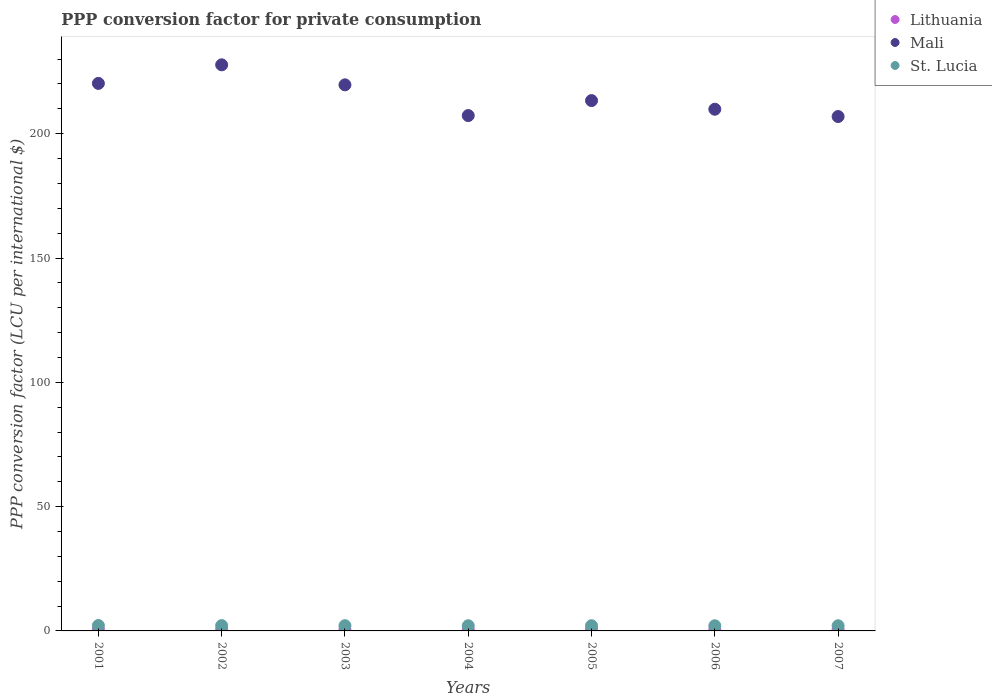What is the PPP conversion factor for private consumption in Mali in 2004?
Your response must be concise. 207.3. Across all years, what is the maximum PPP conversion factor for private consumption in Mali?
Ensure brevity in your answer.  227.71. Across all years, what is the minimum PPP conversion factor for private consumption in Mali?
Your answer should be very brief. 206.91. In which year was the PPP conversion factor for private consumption in St. Lucia minimum?
Make the answer very short. 2006. What is the total PPP conversion factor for private consumption in St. Lucia in the graph?
Provide a succinct answer. 14.71. What is the difference between the PPP conversion factor for private consumption in Lithuania in 2002 and that in 2007?
Give a very brief answer. -0.04. What is the difference between the PPP conversion factor for private consumption in Lithuania in 2003 and the PPP conversion factor for private consumption in Mali in 2001?
Offer a very short reply. -219.78. What is the average PPP conversion factor for private consumption in Lithuania per year?
Your response must be concise. 0.48. In the year 2001, what is the difference between the PPP conversion factor for private consumption in Mali and PPP conversion factor for private consumption in St. Lucia?
Your answer should be compact. 218.07. What is the ratio of the PPP conversion factor for private consumption in Lithuania in 2003 to that in 2007?
Make the answer very short. 0.88. What is the difference between the highest and the second highest PPP conversion factor for private consumption in Lithuania?
Offer a terse response. 0.02. What is the difference between the highest and the lowest PPP conversion factor for private consumption in Mali?
Provide a short and direct response. 20.8. Is the sum of the PPP conversion factor for private consumption in Lithuania in 2001 and 2006 greater than the maximum PPP conversion factor for private consumption in St. Lucia across all years?
Offer a very short reply. No. Is it the case that in every year, the sum of the PPP conversion factor for private consumption in St. Lucia and PPP conversion factor for private consumption in Mali  is greater than the PPP conversion factor for private consumption in Lithuania?
Your answer should be compact. Yes. How many dotlines are there?
Offer a very short reply. 3. Are the values on the major ticks of Y-axis written in scientific E-notation?
Offer a terse response. No. Does the graph contain grids?
Offer a very short reply. No. How many legend labels are there?
Your response must be concise. 3. How are the legend labels stacked?
Your answer should be compact. Vertical. What is the title of the graph?
Your answer should be compact. PPP conversion factor for private consumption. What is the label or title of the X-axis?
Make the answer very short. Years. What is the label or title of the Y-axis?
Make the answer very short. PPP conversion factor (LCU per international $). What is the PPP conversion factor (LCU per international $) of Lithuania in 2001?
Provide a succinct answer. 0.5. What is the PPP conversion factor (LCU per international $) of Mali in 2001?
Provide a succinct answer. 220.24. What is the PPP conversion factor (LCU per international $) in St. Lucia in 2001?
Your answer should be very brief. 2.17. What is the PPP conversion factor (LCU per international $) of Lithuania in 2002?
Give a very brief answer. 0.48. What is the PPP conversion factor (LCU per international $) in Mali in 2002?
Offer a very short reply. 227.71. What is the PPP conversion factor (LCU per international $) in St. Lucia in 2002?
Provide a short and direct response. 2.13. What is the PPP conversion factor (LCU per international $) in Lithuania in 2003?
Your answer should be very brief. 0.46. What is the PPP conversion factor (LCU per international $) of Mali in 2003?
Make the answer very short. 219.66. What is the PPP conversion factor (LCU per international $) of St. Lucia in 2003?
Your answer should be very brief. 2.1. What is the PPP conversion factor (LCU per international $) of Lithuania in 2004?
Keep it short and to the point. 0.46. What is the PPP conversion factor (LCU per international $) in Mali in 2004?
Offer a very short reply. 207.3. What is the PPP conversion factor (LCU per international $) of St. Lucia in 2004?
Keep it short and to the point. 2.08. What is the PPP conversion factor (LCU per international $) of Lithuania in 2005?
Provide a short and direct response. 0.48. What is the PPP conversion factor (LCU per international $) in Mali in 2005?
Offer a very short reply. 213.32. What is the PPP conversion factor (LCU per international $) of St. Lucia in 2005?
Keep it short and to the point. 2.09. What is the PPP conversion factor (LCU per international $) of Lithuania in 2006?
Offer a terse response. 0.49. What is the PPP conversion factor (LCU per international $) in Mali in 2006?
Keep it short and to the point. 209.85. What is the PPP conversion factor (LCU per international $) of St. Lucia in 2006?
Offer a terse response. 2.07. What is the PPP conversion factor (LCU per international $) of Lithuania in 2007?
Make the answer very short. 0.52. What is the PPP conversion factor (LCU per international $) in Mali in 2007?
Provide a succinct answer. 206.91. What is the PPP conversion factor (LCU per international $) of St. Lucia in 2007?
Provide a succinct answer. 2.08. Across all years, what is the maximum PPP conversion factor (LCU per international $) of Lithuania?
Ensure brevity in your answer.  0.52. Across all years, what is the maximum PPP conversion factor (LCU per international $) of Mali?
Offer a terse response. 227.71. Across all years, what is the maximum PPP conversion factor (LCU per international $) in St. Lucia?
Provide a succinct answer. 2.17. Across all years, what is the minimum PPP conversion factor (LCU per international $) of Lithuania?
Provide a succinct answer. 0.46. Across all years, what is the minimum PPP conversion factor (LCU per international $) of Mali?
Provide a short and direct response. 206.91. Across all years, what is the minimum PPP conversion factor (LCU per international $) of St. Lucia?
Provide a short and direct response. 2.07. What is the total PPP conversion factor (LCU per international $) of Lithuania in the graph?
Make the answer very short. 3.38. What is the total PPP conversion factor (LCU per international $) of Mali in the graph?
Make the answer very short. 1504.99. What is the total PPP conversion factor (LCU per international $) in St. Lucia in the graph?
Offer a very short reply. 14.71. What is the difference between the PPP conversion factor (LCU per international $) of Lithuania in 2001 and that in 2002?
Your answer should be compact. 0.02. What is the difference between the PPP conversion factor (LCU per international $) of Mali in 2001 and that in 2002?
Provide a succinct answer. -7.47. What is the difference between the PPP conversion factor (LCU per international $) of St. Lucia in 2001 and that in 2002?
Provide a succinct answer. 0.04. What is the difference between the PPP conversion factor (LCU per international $) of Lithuania in 2001 and that in 2003?
Provide a short and direct response. 0.04. What is the difference between the PPP conversion factor (LCU per international $) of Mali in 2001 and that in 2003?
Your response must be concise. 0.58. What is the difference between the PPP conversion factor (LCU per international $) in St. Lucia in 2001 and that in 2003?
Provide a short and direct response. 0.07. What is the difference between the PPP conversion factor (LCU per international $) in Lithuania in 2001 and that in 2004?
Make the answer very short. 0.03. What is the difference between the PPP conversion factor (LCU per international $) in Mali in 2001 and that in 2004?
Your answer should be compact. 12.94. What is the difference between the PPP conversion factor (LCU per international $) of St. Lucia in 2001 and that in 2004?
Give a very brief answer. 0.09. What is the difference between the PPP conversion factor (LCU per international $) in Lithuania in 2001 and that in 2005?
Make the answer very short. 0.02. What is the difference between the PPP conversion factor (LCU per international $) in Mali in 2001 and that in 2005?
Provide a succinct answer. 6.91. What is the difference between the PPP conversion factor (LCU per international $) in St. Lucia in 2001 and that in 2005?
Offer a terse response. 0.08. What is the difference between the PPP conversion factor (LCU per international $) of Lithuania in 2001 and that in 2006?
Your answer should be very brief. 0. What is the difference between the PPP conversion factor (LCU per international $) in Mali in 2001 and that in 2006?
Provide a short and direct response. 10.39. What is the difference between the PPP conversion factor (LCU per international $) of St. Lucia in 2001 and that in 2006?
Offer a terse response. 0.1. What is the difference between the PPP conversion factor (LCU per international $) of Lithuania in 2001 and that in 2007?
Provide a succinct answer. -0.02. What is the difference between the PPP conversion factor (LCU per international $) of Mali in 2001 and that in 2007?
Your answer should be compact. 13.33. What is the difference between the PPP conversion factor (LCU per international $) in St. Lucia in 2001 and that in 2007?
Offer a very short reply. 0.09. What is the difference between the PPP conversion factor (LCU per international $) of Lithuania in 2002 and that in 2003?
Provide a succinct answer. 0.02. What is the difference between the PPP conversion factor (LCU per international $) of Mali in 2002 and that in 2003?
Provide a short and direct response. 8.05. What is the difference between the PPP conversion factor (LCU per international $) of St. Lucia in 2002 and that in 2003?
Provide a succinct answer. 0.03. What is the difference between the PPP conversion factor (LCU per international $) in Lithuania in 2002 and that in 2004?
Your answer should be very brief. 0.02. What is the difference between the PPP conversion factor (LCU per international $) in Mali in 2002 and that in 2004?
Your answer should be compact. 20.41. What is the difference between the PPP conversion factor (LCU per international $) of St. Lucia in 2002 and that in 2004?
Your response must be concise. 0.05. What is the difference between the PPP conversion factor (LCU per international $) in Lithuania in 2002 and that in 2005?
Keep it short and to the point. 0. What is the difference between the PPP conversion factor (LCU per international $) in Mali in 2002 and that in 2005?
Give a very brief answer. 14.39. What is the difference between the PPP conversion factor (LCU per international $) in St. Lucia in 2002 and that in 2005?
Your response must be concise. 0.04. What is the difference between the PPP conversion factor (LCU per international $) of Lithuania in 2002 and that in 2006?
Make the answer very short. -0.01. What is the difference between the PPP conversion factor (LCU per international $) of Mali in 2002 and that in 2006?
Your answer should be very brief. 17.86. What is the difference between the PPP conversion factor (LCU per international $) of St. Lucia in 2002 and that in 2006?
Offer a very short reply. 0.06. What is the difference between the PPP conversion factor (LCU per international $) in Lithuania in 2002 and that in 2007?
Your answer should be compact. -0.04. What is the difference between the PPP conversion factor (LCU per international $) of Mali in 2002 and that in 2007?
Your answer should be very brief. 20.8. What is the difference between the PPP conversion factor (LCU per international $) of St. Lucia in 2002 and that in 2007?
Provide a short and direct response. 0.05. What is the difference between the PPP conversion factor (LCU per international $) of Lithuania in 2003 and that in 2004?
Offer a very short reply. -0.01. What is the difference between the PPP conversion factor (LCU per international $) of Mali in 2003 and that in 2004?
Ensure brevity in your answer.  12.36. What is the difference between the PPP conversion factor (LCU per international $) in St. Lucia in 2003 and that in 2004?
Offer a terse response. 0.02. What is the difference between the PPP conversion factor (LCU per international $) of Lithuania in 2003 and that in 2005?
Your response must be concise. -0.02. What is the difference between the PPP conversion factor (LCU per international $) in Mali in 2003 and that in 2005?
Give a very brief answer. 6.33. What is the difference between the PPP conversion factor (LCU per international $) of St. Lucia in 2003 and that in 2005?
Your response must be concise. 0.01. What is the difference between the PPP conversion factor (LCU per international $) of Lithuania in 2003 and that in 2006?
Offer a terse response. -0.04. What is the difference between the PPP conversion factor (LCU per international $) of Mali in 2003 and that in 2006?
Your answer should be compact. 9.81. What is the difference between the PPP conversion factor (LCU per international $) in St. Lucia in 2003 and that in 2006?
Make the answer very short. 0.03. What is the difference between the PPP conversion factor (LCU per international $) in Lithuania in 2003 and that in 2007?
Your response must be concise. -0.06. What is the difference between the PPP conversion factor (LCU per international $) in Mali in 2003 and that in 2007?
Provide a succinct answer. 12.75. What is the difference between the PPP conversion factor (LCU per international $) in St. Lucia in 2003 and that in 2007?
Keep it short and to the point. 0.03. What is the difference between the PPP conversion factor (LCU per international $) in Lithuania in 2004 and that in 2005?
Offer a very short reply. -0.01. What is the difference between the PPP conversion factor (LCU per international $) of Mali in 2004 and that in 2005?
Your answer should be compact. -6.03. What is the difference between the PPP conversion factor (LCU per international $) in St. Lucia in 2004 and that in 2005?
Your response must be concise. -0.01. What is the difference between the PPP conversion factor (LCU per international $) of Lithuania in 2004 and that in 2006?
Your answer should be very brief. -0.03. What is the difference between the PPP conversion factor (LCU per international $) in Mali in 2004 and that in 2006?
Keep it short and to the point. -2.55. What is the difference between the PPP conversion factor (LCU per international $) in St. Lucia in 2004 and that in 2006?
Give a very brief answer. 0.01. What is the difference between the PPP conversion factor (LCU per international $) of Lithuania in 2004 and that in 2007?
Offer a very short reply. -0.05. What is the difference between the PPP conversion factor (LCU per international $) in Mali in 2004 and that in 2007?
Provide a succinct answer. 0.39. What is the difference between the PPP conversion factor (LCU per international $) in St. Lucia in 2004 and that in 2007?
Provide a succinct answer. 0. What is the difference between the PPP conversion factor (LCU per international $) in Lithuania in 2005 and that in 2006?
Offer a very short reply. -0.02. What is the difference between the PPP conversion factor (LCU per international $) of Mali in 2005 and that in 2006?
Provide a short and direct response. 3.48. What is the difference between the PPP conversion factor (LCU per international $) of St. Lucia in 2005 and that in 2006?
Provide a short and direct response. 0.02. What is the difference between the PPP conversion factor (LCU per international $) of Lithuania in 2005 and that in 2007?
Your answer should be very brief. -0.04. What is the difference between the PPP conversion factor (LCU per international $) of Mali in 2005 and that in 2007?
Ensure brevity in your answer.  6.42. What is the difference between the PPP conversion factor (LCU per international $) in St. Lucia in 2005 and that in 2007?
Provide a short and direct response. 0.01. What is the difference between the PPP conversion factor (LCU per international $) of Lithuania in 2006 and that in 2007?
Provide a succinct answer. -0.02. What is the difference between the PPP conversion factor (LCU per international $) of Mali in 2006 and that in 2007?
Keep it short and to the point. 2.94. What is the difference between the PPP conversion factor (LCU per international $) in St. Lucia in 2006 and that in 2007?
Your response must be concise. -0. What is the difference between the PPP conversion factor (LCU per international $) in Lithuania in 2001 and the PPP conversion factor (LCU per international $) in Mali in 2002?
Provide a succinct answer. -227.21. What is the difference between the PPP conversion factor (LCU per international $) in Lithuania in 2001 and the PPP conversion factor (LCU per international $) in St. Lucia in 2002?
Provide a succinct answer. -1.63. What is the difference between the PPP conversion factor (LCU per international $) of Mali in 2001 and the PPP conversion factor (LCU per international $) of St. Lucia in 2002?
Ensure brevity in your answer.  218.11. What is the difference between the PPP conversion factor (LCU per international $) of Lithuania in 2001 and the PPP conversion factor (LCU per international $) of Mali in 2003?
Make the answer very short. -219.16. What is the difference between the PPP conversion factor (LCU per international $) of Lithuania in 2001 and the PPP conversion factor (LCU per international $) of St. Lucia in 2003?
Your answer should be very brief. -1.61. What is the difference between the PPP conversion factor (LCU per international $) of Mali in 2001 and the PPP conversion factor (LCU per international $) of St. Lucia in 2003?
Keep it short and to the point. 218.14. What is the difference between the PPP conversion factor (LCU per international $) in Lithuania in 2001 and the PPP conversion factor (LCU per international $) in Mali in 2004?
Your response must be concise. -206.8. What is the difference between the PPP conversion factor (LCU per international $) of Lithuania in 2001 and the PPP conversion factor (LCU per international $) of St. Lucia in 2004?
Your answer should be very brief. -1.58. What is the difference between the PPP conversion factor (LCU per international $) in Mali in 2001 and the PPP conversion factor (LCU per international $) in St. Lucia in 2004?
Provide a short and direct response. 218.16. What is the difference between the PPP conversion factor (LCU per international $) in Lithuania in 2001 and the PPP conversion factor (LCU per international $) in Mali in 2005?
Your answer should be compact. -212.83. What is the difference between the PPP conversion factor (LCU per international $) of Lithuania in 2001 and the PPP conversion factor (LCU per international $) of St. Lucia in 2005?
Offer a very short reply. -1.59. What is the difference between the PPP conversion factor (LCU per international $) of Mali in 2001 and the PPP conversion factor (LCU per international $) of St. Lucia in 2005?
Give a very brief answer. 218.15. What is the difference between the PPP conversion factor (LCU per international $) of Lithuania in 2001 and the PPP conversion factor (LCU per international $) of Mali in 2006?
Offer a terse response. -209.35. What is the difference between the PPP conversion factor (LCU per international $) of Lithuania in 2001 and the PPP conversion factor (LCU per international $) of St. Lucia in 2006?
Provide a short and direct response. -1.57. What is the difference between the PPP conversion factor (LCU per international $) in Mali in 2001 and the PPP conversion factor (LCU per international $) in St. Lucia in 2006?
Give a very brief answer. 218.17. What is the difference between the PPP conversion factor (LCU per international $) of Lithuania in 2001 and the PPP conversion factor (LCU per international $) of Mali in 2007?
Your answer should be very brief. -206.41. What is the difference between the PPP conversion factor (LCU per international $) of Lithuania in 2001 and the PPP conversion factor (LCU per international $) of St. Lucia in 2007?
Provide a short and direct response. -1.58. What is the difference between the PPP conversion factor (LCU per international $) in Mali in 2001 and the PPP conversion factor (LCU per international $) in St. Lucia in 2007?
Give a very brief answer. 218.16. What is the difference between the PPP conversion factor (LCU per international $) of Lithuania in 2002 and the PPP conversion factor (LCU per international $) of Mali in 2003?
Keep it short and to the point. -219.18. What is the difference between the PPP conversion factor (LCU per international $) in Lithuania in 2002 and the PPP conversion factor (LCU per international $) in St. Lucia in 2003?
Keep it short and to the point. -1.62. What is the difference between the PPP conversion factor (LCU per international $) in Mali in 2002 and the PPP conversion factor (LCU per international $) in St. Lucia in 2003?
Provide a short and direct response. 225.61. What is the difference between the PPP conversion factor (LCU per international $) of Lithuania in 2002 and the PPP conversion factor (LCU per international $) of Mali in 2004?
Your answer should be very brief. -206.82. What is the difference between the PPP conversion factor (LCU per international $) in Lithuania in 2002 and the PPP conversion factor (LCU per international $) in St. Lucia in 2004?
Your answer should be very brief. -1.6. What is the difference between the PPP conversion factor (LCU per international $) in Mali in 2002 and the PPP conversion factor (LCU per international $) in St. Lucia in 2004?
Provide a succinct answer. 225.63. What is the difference between the PPP conversion factor (LCU per international $) of Lithuania in 2002 and the PPP conversion factor (LCU per international $) of Mali in 2005?
Your answer should be very brief. -212.84. What is the difference between the PPP conversion factor (LCU per international $) of Lithuania in 2002 and the PPP conversion factor (LCU per international $) of St. Lucia in 2005?
Give a very brief answer. -1.61. What is the difference between the PPP conversion factor (LCU per international $) of Mali in 2002 and the PPP conversion factor (LCU per international $) of St. Lucia in 2005?
Your answer should be compact. 225.62. What is the difference between the PPP conversion factor (LCU per international $) in Lithuania in 2002 and the PPP conversion factor (LCU per international $) in Mali in 2006?
Your answer should be compact. -209.37. What is the difference between the PPP conversion factor (LCU per international $) of Lithuania in 2002 and the PPP conversion factor (LCU per international $) of St. Lucia in 2006?
Ensure brevity in your answer.  -1.59. What is the difference between the PPP conversion factor (LCU per international $) in Mali in 2002 and the PPP conversion factor (LCU per international $) in St. Lucia in 2006?
Your answer should be compact. 225.64. What is the difference between the PPP conversion factor (LCU per international $) of Lithuania in 2002 and the PPP conversion factor (LCU per international $) of Mali in 2007?
Your answer should be very brief. -206.43. What is the difference between the PPP conversion factor (LCU per international $) of Lithuania in 2002 and the PPP conversion factor (LCU per international $) of St. Lucia in 2007?
Make the answer very short. -1.6. What is the difference between the PPP conversion factor (LCU per international $) of Mali in 2002 and the PPP conversion factor (LCU per international $) of St. Lucia in 2007?
Make the answer very short. 225.64. What is the difference between the PPP conversion factor (LCU per international $) in Lithuania in 2003 and the PPP conversion factor (LCU per international $) in Mali in 2004?
Offer a terse response. -206.84. What is the difference between the PPP conversion factor (LCU per international $) of Lithuania in 2003 and the PPP conversion factor (LCU per international $) of St. Lucia in 2004?
Keep it short and to the point. -1.62. What is the difference between the PPP conversion factor (LCU per international $) of Mali in 2003 and the PPP conversion factor (LCU per international $) of St. Lucia in 2004?
Your response must be concise. 217.58. What is the difference between the PPP conversion factor (LCU per international $) of Lithuania in 2003 and the PPP conversion factor (LCU per international $) of Mali in 2005?
Make the answer very short. -212.87. What is the difference between the PPP conversion factor (LCU per international $) of Lithuania in 2003 and the PPP conversion factor (LCU per international $) of St. Lucia in 2005?
Your response must be concise. -1.63. What is the difference between the PPP conversion factor (LCU per international $) of Mali in 2003 and the PPP conversion factor (LCU per international $) of St. Lucia in 2005?
Keep it short and to the point. 217.57. What is the difference between the PPP conversion factor (LCU per international $) in Lithuania in 2003 and the PPP conversion factor (LCU per international $) in Mali in 2006?
Your answer should be compact. -209.39. What is the difference between the PPP conversion factor (LCU per international $) in Lithuania in 2003 and the PPP conversion factor (LCU per international $) in St. Lucia in 2006?
Your response must be concise. -1.62. What is the difference between the PPP conversion factor (LCU per international $) in Mali in 2003 and the PPP conversion factor (LCU per international $) in St. Lucia in 2006?
Make the answer very short. 217.59. What is the difference between the PPP conversion factor (LCU per international $) of Lithuania in 2003 and the PPP conversion factor (LCU per international $) of Mali in 2007?
Your answer should be very brief. -206.45. What is the difference between the PPP conversion factor (LCU per international $) of Lithuania in 2003 and the PPP conversion factor (LCU per international $) of St. Lucia in 2007?
Offer a very short reply. -1.62. What is the difference between the PPP conversion factor (LCU per international $) of Mali in 2003 and the PPP conversion factor (LCU per international $) of St. Lucia in 2007?
Offer a terse response. 217.58. What is the difference between the PPP conversion factor (LCU per international $) of Lithuania in 2004 and the PPP conversion factor (LCU per international $) of Mali in 2005?
Your answer should be compact. -212.86. What is the difference between the PPP conversion factor (LCU per international $) of Lithuania in 2004 and the PPP conversion factor (LCU per international $) of St. Lucia in 2005?
Ensure brevity in your answer.  -1.63. What is the difference between the PPP conversion factor (LCU per international $) in Mali in 2004 and the PPP conversion factor (LCU per international $) in St. Lucia in 2005?
Keep it short and to the point. 205.21. What is the difference between the PPP conversion factor (LCU per international $) of Lithuania in 2004 and the PPP conversion factor (LCU per international $) of Mali in 2006?
Ensure brevity in your answer.  -209.38. What is the difference between the PPP conversion factor (LCU per international $) in Lithuania in 2004 and the PPP conversion factor (LCU per international $) in St. Lucia in 2006?
Offer a terse response. -1.61. What is the difference between the PPP conversion factor (LCU per international $) in Mali in 2004 and the PPP conversion factor (LCU per international $) in St. Lucia in 2006?
Keep it short and to the point. 205.23. What is the difference between the PPP conversion factor (LCU per international $) of Lithuania in 2004 and the PPP conversion factor (LCU per international $) of Mali in 2007?
Offer a terse response. -206.44. What is the difference between the PPP conversion factor (LCU per international $) in Lithuania in 2004 and the PPP conversion factor (LCU per international $) in St. Lucia in 2007?
Provide a succinct answer. -1.61. What is the difference between the PPP conversion factor (LCU per international $) in Mali in 2004 and the PPP conversion factor (LCU per international $) in St. Lucia in 2007?
Make the answer very short. 205.22. What is the difference between the PPP conversion factor (LCU per international $) in Lithuania in 2005 and the PPP conversion factor (LCU per international $) in Mali in 2006?
Offer a very short reply. -209.37. What is the difference between the PPP conversion factor (LCU per international $) of Lithuania in 2005 and the PPP conversion factor (LCU per international $) of St. Lucia in 2006?
Offer a terse response. -1.59. What is the difference between the PPP conversion factor (LCU per international $) in Mali in 2005 and the PPP conversion factor (LCU per international $) in St. Lucia in 2006?
Provide a succinct answer. 211.25. What is the difference between the PPP conversion factor (LCU per international $) of Lithuania in 2005 and the PPP conversion factor (LCU per international $) of Mali in 2007?
Offer a terse response. -206.43. What is the difference between the PPP conversion factor (LCU per international $) of Lithuania in 2005 and the PPP conversion factor (LCU per international $) of St. Lucia in 2007?
Keep it short and to the point. -1.6. What is the difference between the PPP conversion factor (LCU per international $) in Mali in 2005 and the PPP conversion factor (LCU per international $) in St. Lucia in 2007?
Make the answer very short. 211.25. What is the difference between the PPP conversion factor (LCU per international $) in Lithuania in 2006 and the PPP conversion factor (LCU per international $) in Mali in 2007?
Ensure brevity in your answer.  -206.42. What is the difference between the PPP conversion factor (LCU per international $) in Lithuania in 2006 and the PPP conversion factor (LCU per international $) in St. Lucia in 2007?
Offer a very short reply. -1.58. What is the difference between the PPP conversion factor (LCU per international $) in Mali in 2006 and the PPP conversion factor (LCU per international $) in St. Lucia in 2007?
Provide a short and direct response. 207.77. What is the average PPP conversion factor (LCU per international $) in Lithuania per year?
Provide a succinct answer. 0.48. What is the average PPP conversion factor (LCU per international $) of Mali per year?
Offer a very short reply. 215. What is the average PPP conversion factor (LCU per international $) in St. Lucia per year?
Your answer should be very brief. 2.1. In the year 2001, what is the difference between the PPP conversion factor (LCU per international $) of Lithuania and PPP conversion factor (LCU per international $) of Mali?
Provide a short and direct response. -219.74. In the year 2001, what is the difference between the PPP conversion factor (LCU per international $) of Lithuania and PPP conversion factor (LCU per international $) of St. Lucia?
Offer a terse response. -1.67. In the year 2001, what is the difference between the PPP conversion factor (LCU per international $) of Mali and PPP conversion factor (LCU per international $) of St. Lucia?
Provide a succinct answer. 218.07. In the year 2002, what is the difference between the PPP conversion factor (LCU per international $) in Lithuania and PPP conversion factor (LCU per international $) in Mali?
Your answer should be compact. -227.23. In the year 2002, what is the difference between the PPP conversion factor (LCU per international $) of Lithuania and PPP conversion factor (LCU per international $) of St. Lucia?
Make the answer very short. -1.65. In the year 2002, what is the difference between the PPP conversion factor (LCU per international $) in Mali and PPP conversion factor (LCU per international $) in St. Lucia?
Offer a very short reply. 225.58. In the year 2003, what is the difference between the PPP conversion factor (LCU per international $) of Lithuania and PPP conversion factor (LCU per international $) of Mali?
Provide a short and direct response. -219.2. In the year 2003, what is the difference between the PPP conversion factor (LCU per international $) in Lithuania and PPP conversion factor (LCU per international $) in St. Lucia?
Provide a succinct answer. -1.65. In the year 2003, what is the difference between the PPP conversion factor (LCU per international $) in Mali and PPP conversion factor (LCU per international $) in St. Lucia?
Your answer should be compact. 217.55. In the year 2004, what is the difference between the PPP conversion factor (LCU per international $) of Lithuania and PPP conversion factor (LCU per international $) of Mali?
Keep it short and to the point. -206.84. In the year 2004, what is the difference between the PPP conversion factor (LCU per international $) in Lithuania and PPP conversion factor (LCU per international $) in St. Lucia?
Make the answer very short. -1.61. In the year 2004, what is the difference between the PPP conversion factor (LCU per international $) of Mali and PPP conversion factor (LCU per international $) of St. Lucia?
Keep it short and to the point. 205.22. In the year 2005, what is the difference between the PPP conversion factor (LCU per international $) in Lithuania and PPP conversion factor (LCU per international $) in Mali?
Ensure brevity in your answer.  -212.85. In the year 2005, what is the difference between the PPP conversion factor (LCU per international $) of Lithuania and PPP conversion factor (LCU per international $) of St. Lucia?
Provide a short and direct response. -1.61. In the year 2005, what is the difference between the PPP conversion factor (LCU per international $) of Mali and PPP conversion factor (LCU per international $) of St. Lucia?
Provide a succinct answer. 211.24. In the year 2006, what is the difference between the PPP conversion factor (LCU per international $) in Lithuania and PPP conversion factor (LCU per international $) in Mali?
Give a very brief answer. -209.36. In the year 2006, what is the difference between the PPP conversion factor (LCU per international $) of Lithuania and PPP conversion factor (LCU per international $) of St. Lucia?
Your answer should be compact. -1.58. In the year 2006, what is the difference between the PPP conversion factor (LCU per international $) of Mali and PPP conversion factor (LCU per international $) of St. Lucia?
Provide a short and direct response. 207.78. In the year 2007, what is the difference between the PPP conversion factor (LCU per international $) of Lithuania and PPP conversion factor (LCU per international $) of Mali?
Provide a short and direct response. -206.39. In the year 2007, what is the difference between the PPP conversion factor (LCU per international $) of Lithuania and PPP conversion factor (LCU per international $) of St. Lucia?
Keep it short and to the point. -1.56. In the year 2007, what is the difference between the PPP conversion factor (LCU per international $) of Mali and PPP conversion factor (LCU per international $) of St. Lucia?
Give a very brief answer. 204.83. What is the ratio of the PPP conversion factor (LCU per international $) in Lithuania in 2001 to that in 2002?
Provide a short and direct response. 1.04. What is the ratio of the PPP conversion factor (LCU per international $) in Mali in 2001 to that in 2002?
Provide a short and direct response. 0.97. What is the ratio of the PPP conversion factor (LCU per international $) of St. Lucia in 2001 to that in 2002?
Provide a succinct answer. 1.02. What is the ratio of the PPP conversion factor (LCU per international $) in Lithuania in 2001 to that in 2003?
Ensure brevity in your answer.  1.09. What is the ratio of the PPP conversion factor (LCU per international $) of Mali in 2001 to that in 2003?
Offer a very short reply. 1. What is the ratio of the PPP conversion factor (LCU per international $) of St. Lucia in 2001 to that in 2003?
Your response must be concise. 1.03. What is the ratio of the PPP conversion factor (LCU per international $) of Lithuania in 2001 to that in 2004?
Keep it short and to the point. 1.07. What is the ratio of the PPP conversion factor (LCU per international $) in Mali in 2001 to that in 2004?
Offer a terse response. 1.06. What is the ratio of the PPP conversion factor (LCU per international $) of St. Lucia in 2001 to that in 2004?
Offer a terse response. 1.04. What is the ratio of the PPP conversion factor (LCU per international $) in Lithuania in 2001 to that in 2005?
Your answer should be very brief. 1.04. What is the ratio of the PPP conversion factor (LCU per international $) of Mali in 2001 to that in 2005?
Make the answer very short. 1.03. What is the ratio of the PPP conversion factor (LCU per international $) in St. Lucia in 2001 to that in 2005?
Offer a terse response. 1.04. What is the ratio of the PPP conversion factor (LCU per international $) in Lithuania in 2001 to that in 2006?
Provide a short and direct response. 1.01. What is the ratio of the PPP conversion factor (LCU per international $) in Mali in 2001 to that in 2006?
Offer a very short reply. 1.05. What is the ratio of the PPP conversion factor (LCU per international $) of St. Lucia in 2001 to that in 2006?
Keep it short and to the point. 1.05. What is the ratio of the PPP conversion factor (LCU per international $) in Lithuania in 2001 to that in 2007?
Provide a succinct answer. 0.96. What is the ratio of the PPP conversion factor (LCU per international $) in Mali in 2001 to that in 2007?
Make the answer very short. 1.06. What is the ratio of the PPP conversion factor (LCU per international $) in St. Lucia in 2001 to that in 2007?
Your response must be concise. 1.04. What is the ratio of the PPP conversion factor (LCU per international $) of Lithuania in 2002 to that in 2003?
Give a very brief answer. 1.05. What is the ratio of the PPP conversion factor (LCU per international $) of Mali in 2002 to that in 2003?
Offer a terse response. 1.04. What is the ratio of the PPP conversion factor (LCU per international $) in St. Lucia in 2002 to that in 2003?
Offer a very short reply. 1.01. What is the ratio of the PPP conversion factor (LCU per international $) of Lithuania in 2002 to that in 2004?
Your response must be concise. 1.03. What is the ratio of the PPP conversion factor (LCU per international $) of Mali in 2002 to that in 2004?
Give a very brief answer. 1.1. What is the ratio of the PPP conversion factor (LCU per international $) in St. Lucia in 2002 to that in 2004?
Provide a short and direct response. 1.02. What is the ratio of the PPP conversion factor (LCU per international $) in Mali in 2002 to that in 2005?
Your answer should be compact. 1.07. What is the ratio of the PPP conversion factor (LCU per international $) in St. Lucia in 2002 to that in 2005?
Provide a short and direct response. 1.02. What is the ratio of the PPP conversion factor (LCU per international $) of Lithuania in 2002 to that in 2006?
Your answer should be compact. 0.97. What is the ratio of the PPP conversion factor (LCU per international $) of Mali in 2002 to that in 2006?
Offer a terse response. 1.09. What is the ratio of the PPP conversion factor (LCU per international $) in St. Lucia in 2002 to that in 2006?
Keep it short and to the point. 1.03. What is the ratio of the PPP conversion factor (LCU per international $) of Lithuania in 2002 to that in 2007?
Your response must be concise. 0.93. What is the ratio of the PPP conversion factor (LCU per international $) in Mali in 2002 to that in 2007?
Provide a succinct answer. 1.1. What is the ratio of the PPP conversion factor (LCU per international $) of St. Lucia in 2002 to that in 2007?
Your response must be concise. 1.03. What is the ratio of the PPP conversion factor (LCU per international $) of Lithuania in 2003 to that in 2004?
Your answer should be very brief. 0.98. What is the ratio of the PPP conversion factor (LCU per international $) in Mali in 2003 to that in 2004?
Offer a very short reply. 1.06. What is the ratio of the PPP conversion factor (LCU per international $) in St. Lucia in 2003 to that in 2004?
Give a very brief answer. 1.01. What is the ratio of the PPP conversion factor (LCU per international $) in Lithuania in 2003 to that in 2005?
Your response must be concise. 0.96. What is the ratio of the PPP conversion factor (LCU per international $) in Mali in 2003 to that in 2005?
Your response must be concise. 1.03. What is the ratio of the PPP conversion factor (LCU per international $) in Lithuania in 2003 to that in 2006?
Ensure brevity in your answer.  0.92. What is the ratio of the PPP conversion factor (LCU per international $) of Mali in 2003 to that in 2006?
Provide a succinct answer. 1.05. What is the ratio of the PPP conversion factor (LCU per international $) in St. Lucia in 2003 to that in 2006?
Give a very brief answer. 1.02. What is the ratio of the PPP conversion factor (LCU per international $) of Lithuania in 2003 to that in 2007?
Make the answer very short. 0.88. What is the ratio of the PPP conversion factor (LCU per international $) of Mali in 2003 to that in 2007?
Offer a very short reply. 1.06. What is the ratio of the PPP conversion factor (LCU per international $) in St. Lucia in 2003 to that in 2007?
Offer a terse response. 1.01. What is the ratio of the PPP conversion factor (LCU per international $) in Lithuania in 2004 to that in 2005?
Keep it short and to the point. 0.97. What is the ratio of the PPP conversion factor (LCU per international $) in Mali in 2004 to that in 2005?
Your answer should be very brief. 0.97. What is the ratio of the PPP conversion factor (LCU per international $) in St. Lucia in 2004 to that in 2005?
Provide a succinct answer. 0.99. What is the ratio of the PPP conversion factor (LCU per international $) in Lithuania in 2004 to that in 2006?
Your answer should be compact. 0.94. What is the ratio of the PPP conversion factor (LCU per international $) in Mali in 2004 to that in 2006?
Your answer should be very brief. 0.99. What is the ratio of the PPP conversion factor (LCU per international $) in St. Lucia in 2004 to that in 2006?
Make the answer very short. 1. What is the ratio of the PPP conversion factor (LCU per international $) in Lithuania in 2004 to that in 2007?
Ensure brevity in your answer.  0.9. What is the ratio of the PPP conversion factor (LCU per international $) of Lithuania in 2005 to that in 2006?
Provide a succinct answer. 0.97. What is the ratio of the PPP conversion factor (LCU per international $) in Mali in 2005 to that in 2006?
Keep it short and to the point. 1.02. What is the ratio of the PPP conversion factor (LCU per international $) of St. Lucia in 2005 to that in 2006?
Your answer should be very brief. 1.01. What is the ratio of the PPP conversion factor (LCU per international $) of Lithuania in 2005 to that in 2007?
Your answer should be very brief. 0.92. What is the ratio of the PPP conversion factor (LCU per international $) of Mali in 2005 to that in 2007?
Offer a very short reply. 1.03. What is the ratio of the PPP conversion factor (LCU per international $) of Lithuania in 2006 to that in 2007?
Make the answer very short. 0.95. What is the ratio of the PPP conversion factor (LCU per international $) in Mali in 2006 to that in 2007?
Offer a very short reply. 1.01. What is the difference between the highest and the second highest PPP conversion factor (LCU per international $) in Lithuania?
Give a very brief answer. 0.02. What is the difference between the highest and the second highest PPP conversion factor (LCU per international $) of Mali?
Offer a terse response. 7.47. What is the difference between the highest and the second highest PPP conversion factor (LCU per international $) of St. Lucia?
Provide a short and direct response. 0.04. What is the difference between the highest and the lowest PPP conversion factor (LCU per international $) in Lithuania?
Give a very brief answer. 0.06. What is the difference between the highest and the lowest PPP conversion factor (LCU per international $) in Mali?
Keep it short and to the point. 20.8. What is the difference between the highest and the lowest PPP conversion factor (LCU per international $) of St. Lucia?
Your answer should be compact. 0.1. 